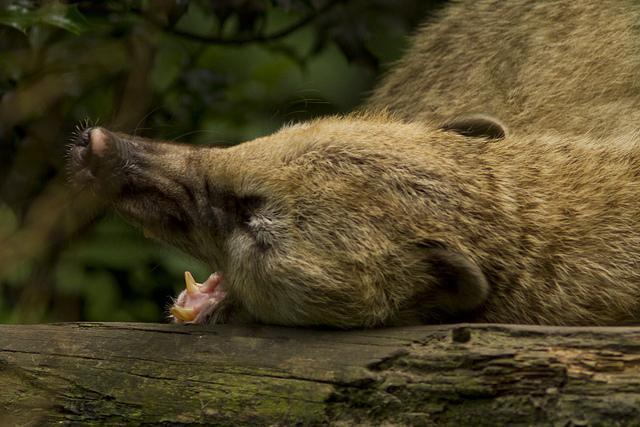How many teeth are showing on the bear?
Give a very brief answer. 2. How many bears are there?
Give a very brief answer. 1. 